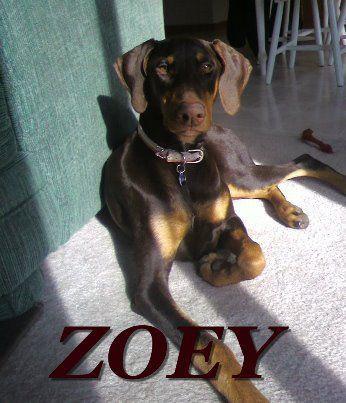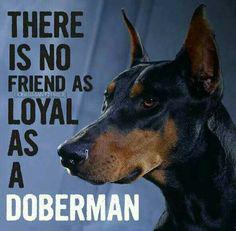The first image is the image on the left, the second image is the image on the right. Given the left and right images, does the statement "In the image on the right, a dog is looking to the left." hold true? Answer yes or no. Yes. The first image is the image on the left, the second image is the image on the right. Analyze the images presented: Is the assertion "There are two dogs, and one of the dogs has cropped ears, while the other dog's ears are uncropped." valid? Answer yes or no. Yes. 